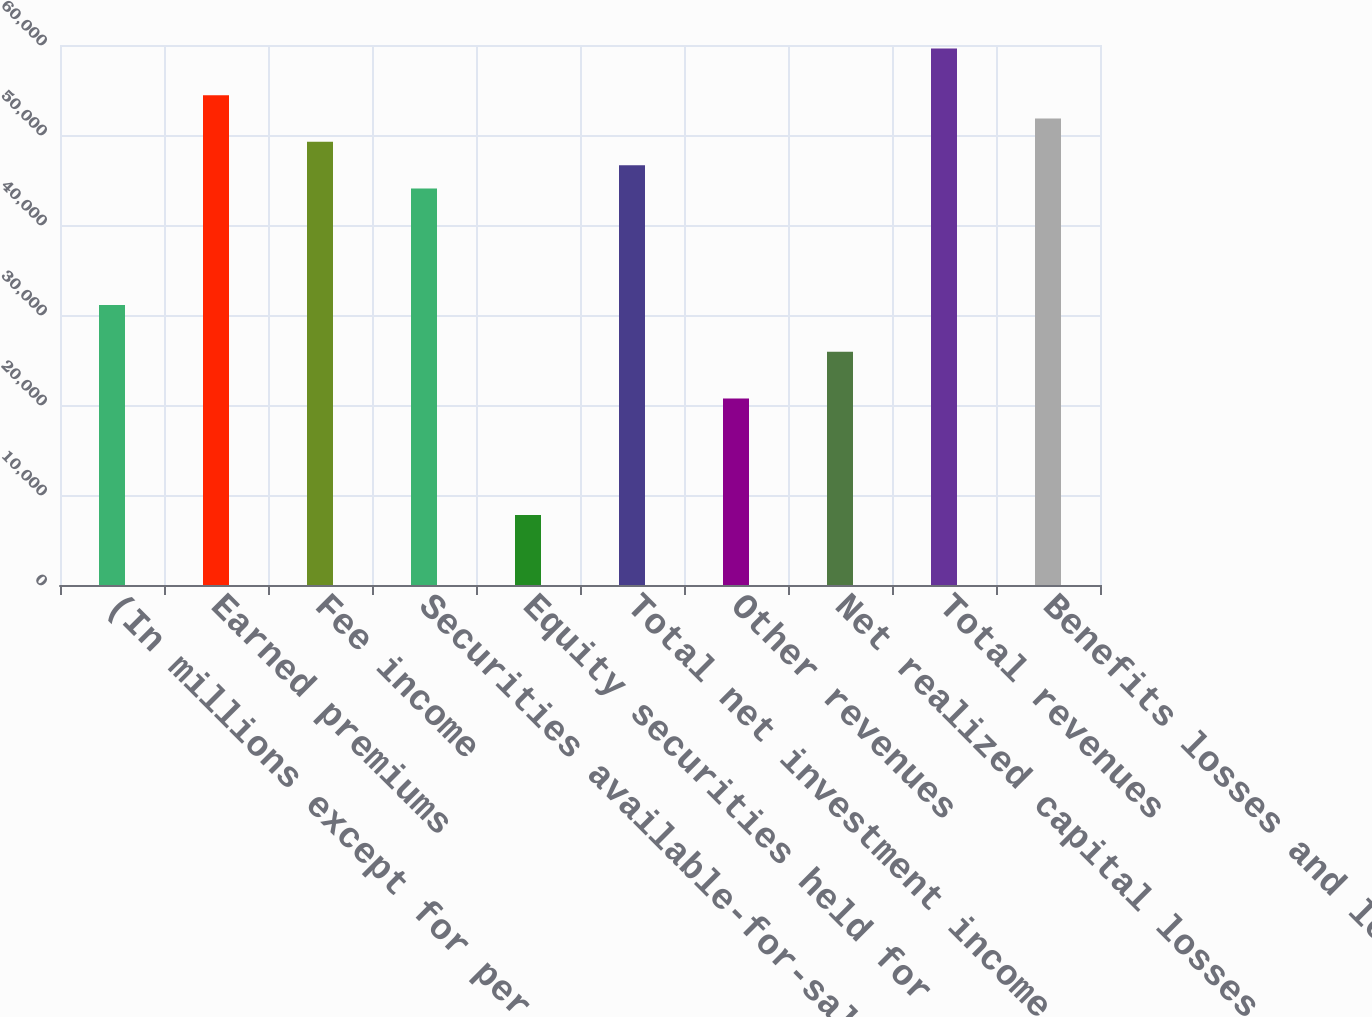Convert chart. <chart><loc_0><loc_0><loc_500><loc_500><bar_chart><fcel>(In millions except for per<fcel>Earned premiums<fcel>Fee income<fcel>Securities available-for-sale<fcel>Equity securities held for<fcel>Total net investment income<fcel>Other revenues<fcel>Net realized capital losses<fcel>Total revenues<fcel>Benefits losses and loss<nl><fcel>31098.8<fcel>54421.4<fcel>49238.6<fcel>44055.8<fcel>7776.23<fcel>46647.2<fcel>20733.2<fcel>25916<fcel>59604.2<fcel>51830<nl></chart> 